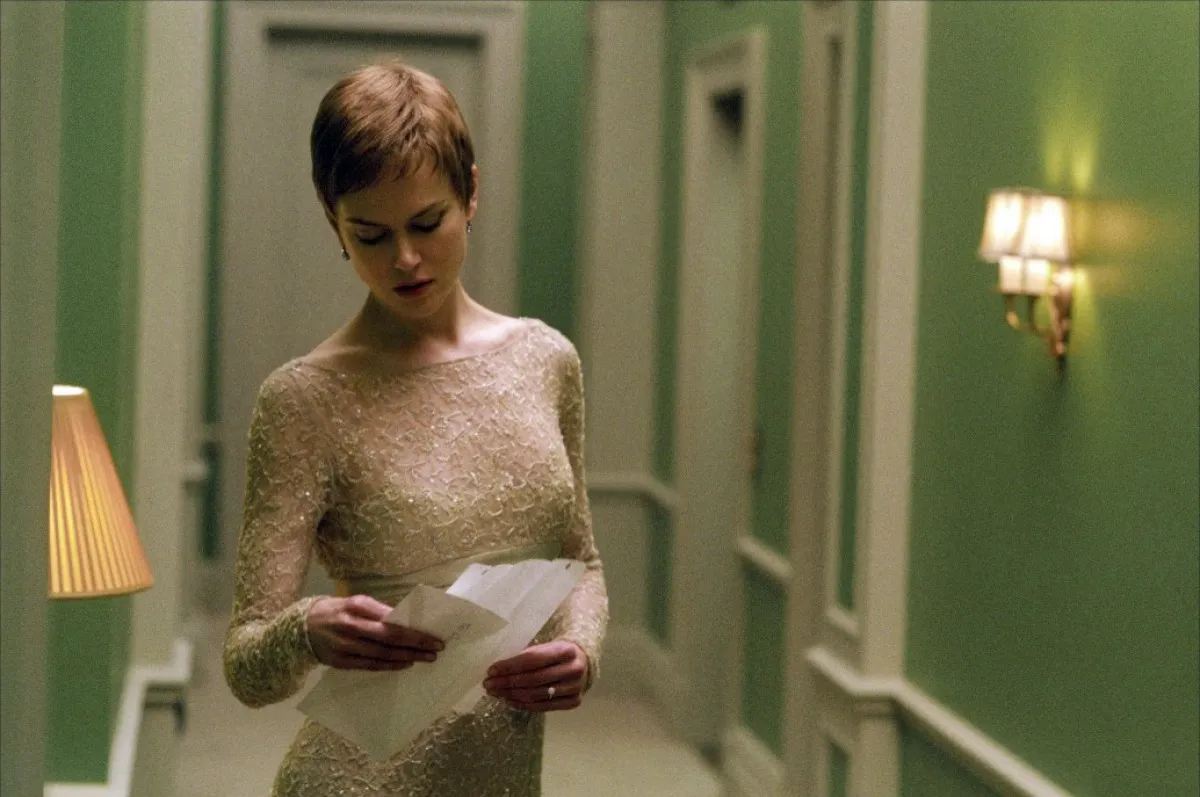What might the letter in the woman's hands contain? Given her contemplative expression and the serene setting, the letter might contain personal or significant professional information that requires her thoughtful attention. 